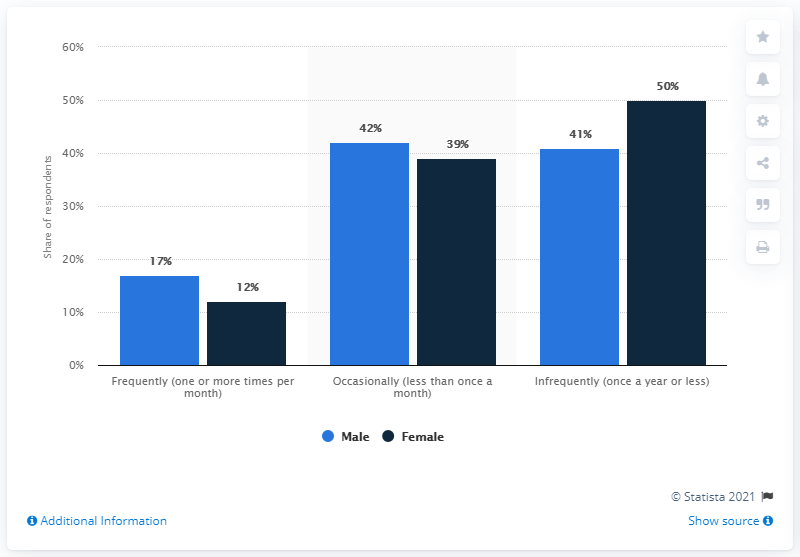Identify some key points in this picture. According to the survey, 29% of respondents reported that they frequently go to the movies at the theater. The chart shows the bar percentages of a certain topic, and the lowest bar percentage is 12 percent. 